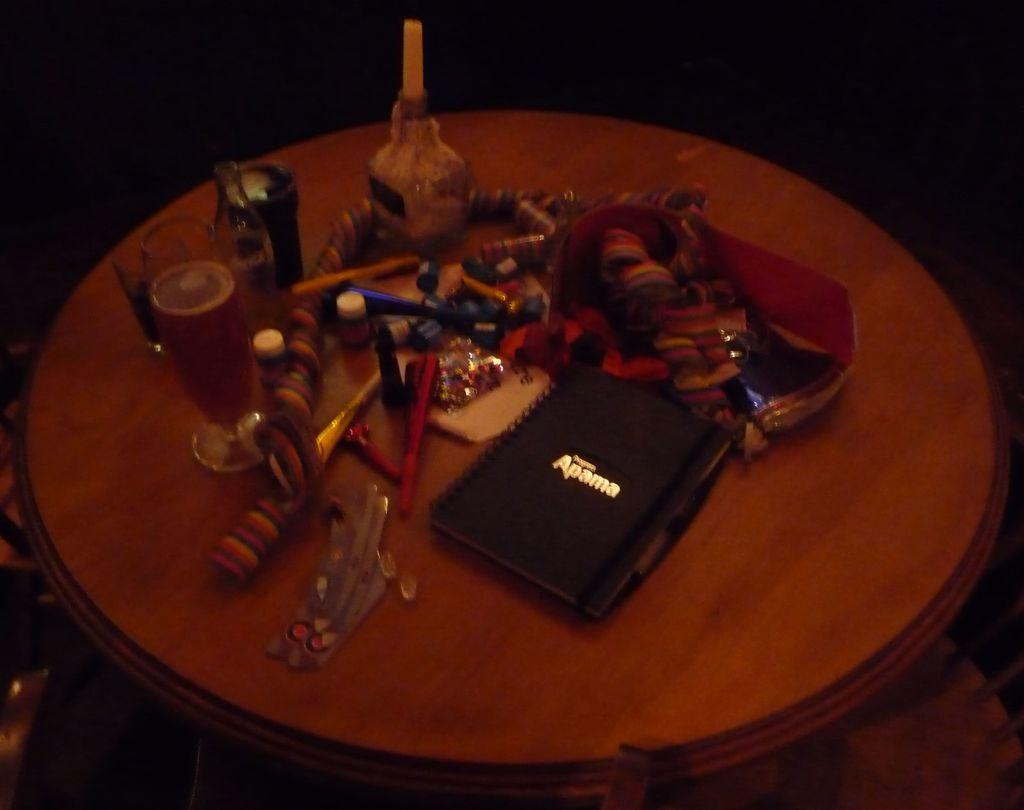<image>
Render a clear and concise summary of the photo. an apama branded case sitting on a table with a cup with drink inside it. 